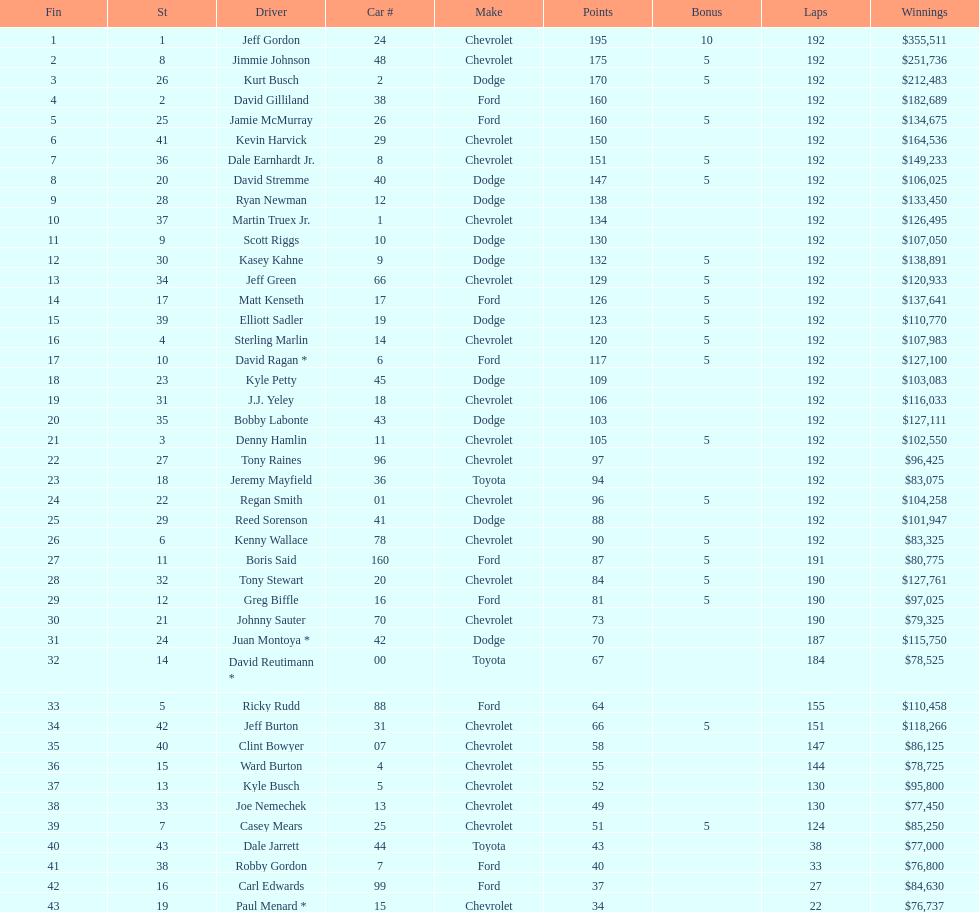How many drivers ranked below tony stewart? 15. 